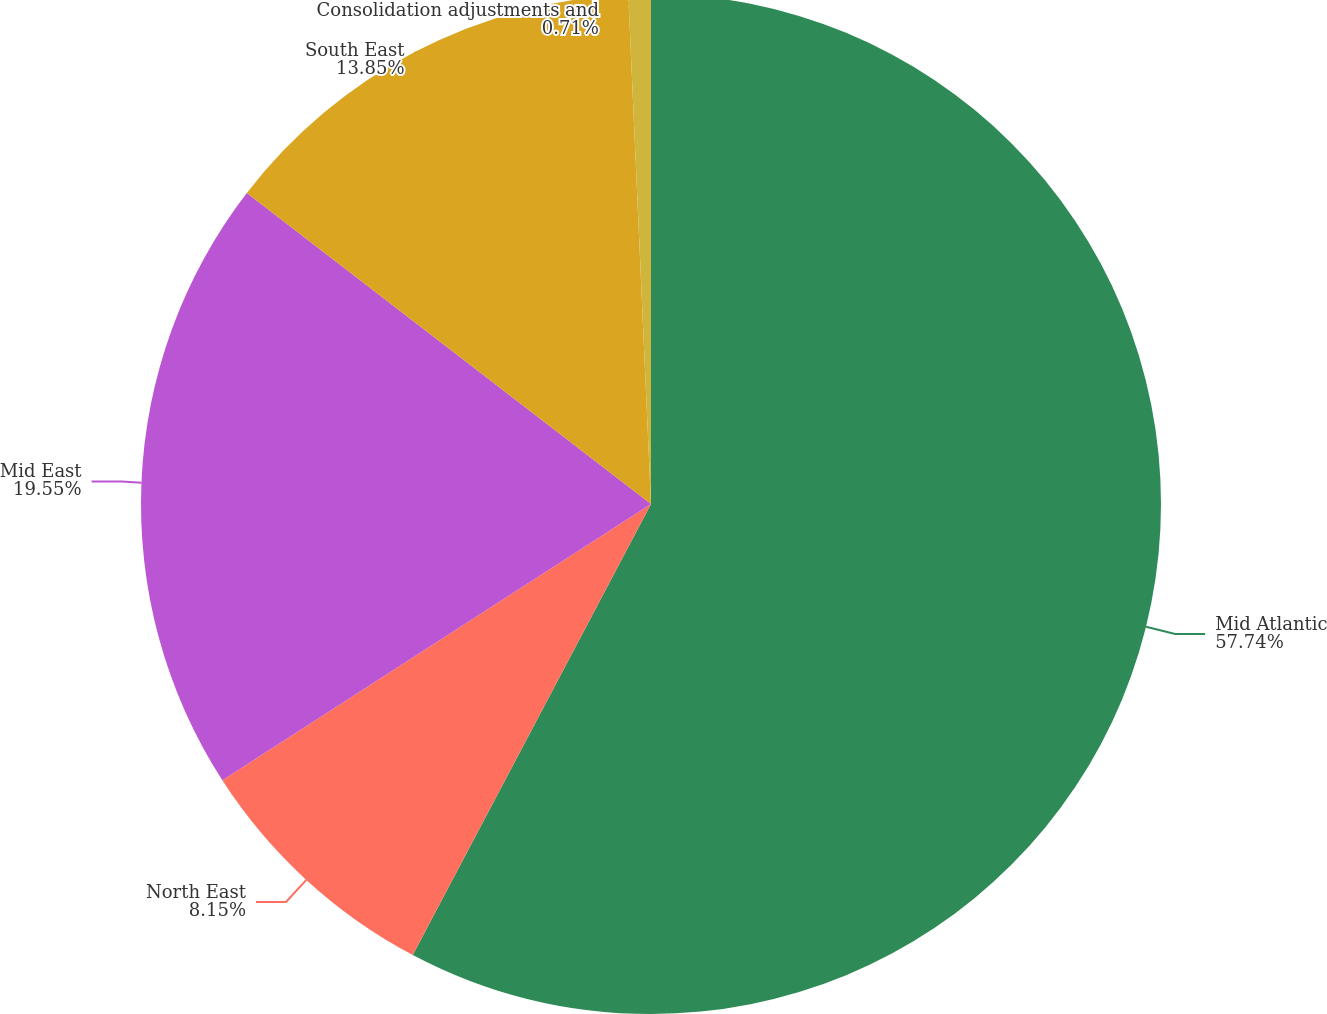<chart> <loc_0><loc_0><loc_500><loc_500><pie_chart><fcel>Mid Atlantic<fcel>North East<fcel>Mid East<fcel>South East<fcel>Consolidation adjustments and<nl><fcel>57.73%<fcel>8.15%<fcel>19.55%<fcel>13.85%<fcel>0.71%<nl></chart> 